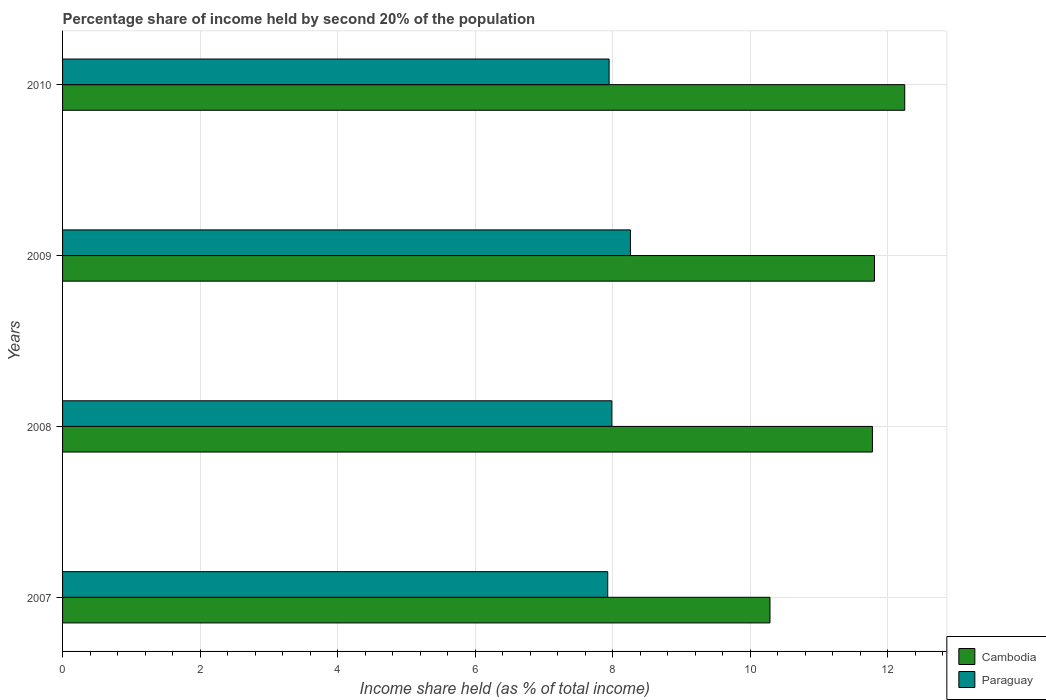How many different coloured bars are there?
Your response must be concise. 2. How many groups of bars are there?
Offer a very short reply. 4. Are the number of bars per tick equal to the number of legend labels?
Your answer should be compact. Yes. How many bars are there on the 2nd tick from the top?
Offer a very short reply. 2. How many bars are there on the 4th tick from the bottom?
Offer a terse response. 2. What is the label of the 3rd group of bars from the top?
Your response must be concise. 2008. In how many cases, is the number of bars for a given year not equal to the number of legend labels?
Provide a succinct answer. 0. What is the share of income held by second 20% of the population in Cambodia in 2008?
Provide a short and direct response. 11.78. Across all years, what is the maximum share of income held by second 20% of the population in Cambodia?
Give a very brief answer. 12.25. Across all years, what is the minimum share of income held by second 20% of the population in Cambodia?
Give a very brief answer. 10.29. What is the total share of income held by second 20% of the population in Paraguay in the graph?
Provide a succinct answer. 32.13. What is the difference between the share of income held by second 20% of the population in Cambodia in 2009 and that in 2010?
Offer a terse response. -0.44. What is the difference between the share of income held by second 20% of the population in Cambodia in 2010 and the share of income held by second 20% of the population in Paraguay in 2007?
Your answer should be very brief. 4.32. What is the average share of income held by second 20% of the population in Cambodia per year?
Make the answer very short. 11.53. In the year 2007, what is the difference between the share of income held by second 20% of the population in Paraguay and share of income held by second 20% of the population in Cambodia?
Offer a very short reply. -2.36. What is the ratio of the share of income held by second 20% of the population in Cambodia in 2007 to that in 2008?
Keep it short and to the point. 0.87. Is the share of income held by second 20% of the population in Cambodia in 2007 less than that in 2009?
Give a very brief answer. Yes. Is the difference between the share of income held by second 20% of the population in Paraguay in 2008 and 2010 greater than the difference between the share of income held by second 20% of the population in Cambodia in 2008 and 2010?
Keep it short and to the point. Yes. What is the difference between the highest and the second highest share of income held by second 20% of the population in Paraguay?
Ensure brevity in your answer.  0.27. What is the difference between the highest and the lowest share of income held by second 20% of the population in Paraguay?
Provide a short and direct response. 0.33. In how many years, is the share of income held by second 20% of the population in Paraguay greater than the average share of income held by second 20% of the population in Paraguay taken over all years?
Keep it short and to the point. 1. What does the 2nd bar from the top in 2010 represents?
Your answer should be compact. Cambodia. What does the 1st bar from the bottom in 2010 represents?
Provide a succinct answer. Cambodia. How many bars are there?
Your answer should be very brief. 8. Are all the bars in the graph horizontal?
Keep it short and to the point. Yes. How many years are there in the graph?
Offer a very short reply. 4. What is the difference between two consecutive major ticks on the X-axis?
Keep it short and to the point. 2. Are the values on the major ticks of X-axis written in scientific E-notation?
Make the answer very short. No. How many legend labels are there?
Make the answer very short. 2. What is the title of the graph?
Give a very brief answer. Percentage share of income held by second 20% of the population. Does "Russian Federation" appear as one of the legend labels in the graph?
Your response must be concise. No. What is the label or title of the X-axis?
Offer a terse response. Income share held (as % of total income). What is the Income share held (as % of total income) of Cambodia in 2007?
Offer a terse response. 10.29. What is the Income share held (as % of total income) in Paraguay in 2007?
Ensure brevity in your answer.  7.93. What is the Income share held (as % of total income) in Cambodia in 2008?
Give a very brief answer. 11.78. What is the Income share held (as % of total income) in Paraguay in 2008?
Your answer should be very brief. 7.99. What is the Income share held (as % of total income) in Cambodia in 2009?
Ensure brevity in your answer.  11.81. What is the Income share held (as % of total income) in Paraguay in 2009?
Offer a very short reply. 8.26. What is the Income share held (as % of total income) in Cambodia in 2010?
Provide a succinct answer. 12.25. What is the Income share held (as % of total income) of Paraguay in 2010?
Offer a terse response. 7.95. Across all years, what is the maximum Income share held (as % of total income) of Cambodia?
Ensure brevity in your answer.  12.25. Across all years, what is the maximum Income share held (as % of total income) of Paraguay?
Your response must be concise. 8.26. Across all years, what is the minimum Income share held (as % of total income) in Cambodia?
Make the answer very short. 10.29. Across all years, what is the minimum Income share held (as % of total income) of Paraguay?
Your answer should be compact. 7.93. What is the total Income share held (as % of total income) in Cambodia in the graph?
Ensure brevity in your answer.  46.13. What is the total Income share held (as % of total income) of Paraguay in the graph?
Provide a short and direct response. 32.13. What is the difference between the Income share held (as % of total income) of Cambodia in 2007 and that in 2008?
Provide a succinct answer. -1.49. What is the difference between the Income share held (as % of total income) in Paraguay in 2007 and that in 2008?
Ensure brevity in your answer.  -0.06. What is the difference between the Income share held (as % of total income) of Cambodia in 2007 and that in 2009?
Your answer should be very brief. -1.52. What is the difference between the Income share held (as % of total income) in Paraguay in 2007 and that in 2009?
Offer a very short reply. -0.33. What is the difference between the Income share held (as % of total income) of Cambodia in 2007 and that in 2010?
Your response must be concise. -1.96. What is the difference between the Income share held (as % of total income) in Paraguay in 2007 and that in 2010?
Your response must be concise. -0.02. What is the difference between the Income share held (as % of total income) of Cambodia in 2008 and that in 2009?
Provide a succinct answer. -0.03. What is the difference between the Income share held (as % of total income) of Paraguay in 2008 and that in 2009?
Offer a very short reply. -0.27. What is the difference between the Income share held (as % of total income) in Cambodia in 2008 and that in 2010?
Make the answer very short. -0.47. What is the difference between the Income share held (as % of total income) of Cambodia in 2009 and that in 2010?
Keep it short and to the point. -0.44. What is the difference between the Income share held (as % of total income) of Paraguay in 2009 and that in 2010?
Make the answer very short. 0.31. What is the difference between the Income share held (as % of total income) in Cambodia in 2007 and the Income share held (as % of total income) in Paraguay in 2008?
Your response must be concise. 2.3. What is the difference between the Income share held (as % of total income) of Cambodia in 2007 and the Income share held (as % of total income) of Paraguay in 2009?
Make the answer very short. 2.03. What is the difference between the Income share held (as % of total income) of Cambodia in 2007 and the Income share held (as % of total income) of Paraguay in 2010?
Offer a terse response. 2.34. What is the difference between the Income share held (as % of total income) in Cambodia in 2008 and the Income share held (as % of total income) in Paraguay in 2009?
Your answer should be very brief. 3.52. What is the difference between the Income share held (as % of total income) of Cambodia in 2008 and the Income share held (as % of total income) of Paraguay in 2010?
Your response must be concise. 3.83. What is the difference between the Income share held (as % of total income) of Cambodia in 2009 and the Income share held (as % of total income) of Paraguay in 2010?
Give a very brief answer. 3.86. What is the average Income share held (as % of total income) in Cambodia per year?
Ensure brevity in your answer.  11.53. What is the average Income share held (as % of total income) of Paraguay per year?
Your answer should be very brief. 8.03. In the year 2007, what is the difference between the Income share held (as % of total income) of Cambodia and Income share held (as % of total income) of Paraguay?
Your answer should be compact. 2.36. In the year 2008, what is the difference between the Income share held (as % of total income) of Cambodia and Income share held (as % of total income) of Paraguay?
Ensure brevity in your answer.  3.79. In the year 2009, what is the difference between the Income share held (as % of total income) in Cambodia and Income share held (as % of total income) in Paraguay?
Your answer should be very brief. 3.55. In the year 2010, what is the difference between the Income share held (as % of total income) in Cambodia and Income share held (as % of total income) in Paraguay?
Your answer should be very brief. 4.3. What is the ratio of the Income share held (as % of total income) in Cambodia in 2007 to that in 2008?
Make the answer very short. 0.87. What is the ratio of the Income share held (as % of total income) in Cambodia in 2007 to that in 2009?
Offer a very short reply. 0.87. What is the ratio of the Income share held (as % of total income) of Paraguay in 2007 to that in 2009?
Offer a terse response. 0.96. What is the ratio of the Income share held (as % of total income) in Cambodia in 2007 to that in 2010?
Offer a very short reply. 0.84. What is the ratio of the Income share held (as % of total income) in Paraguay in 2007 to that in 2010?
Provide a succinct answer. 1. What is the ratio of the Income share held (as % of total income) in Paraguay in 2008 to that in 2009?
Offer a terse response. 0.97. What is the ratio of the Income share held (as % of total income) of Cambodia in 2008 to that in 2010?
Ensure brevity in your answer.  0.96. What is the ratio of the Income share held (as % of total income) of Cambodia in 2009 to that in 2010?
Offer a very short reply. 0.96. What is the ratio of the Income share held (as % of total income) of Paraguay in 2009 to that in 2010?
Your response must be concise. 1.04. What is the difference between the highest and the second highest Income share held (as % of total income) of Cambodia?
Your response must be concise. 0.44. What is the difference between the highest and the second highest Income share held (as % of total income) in Paraguay?
Provide a succinct answer. 0.27. What is the difference between the highest and the lowest Income share held (as % of total income) in Cambodia?
Provide a short and direct response. 1.96. What is the difference between the highest and the lowest Income share held (as % of total income) of Paraguay?
Make the answer very short. 0.33. 